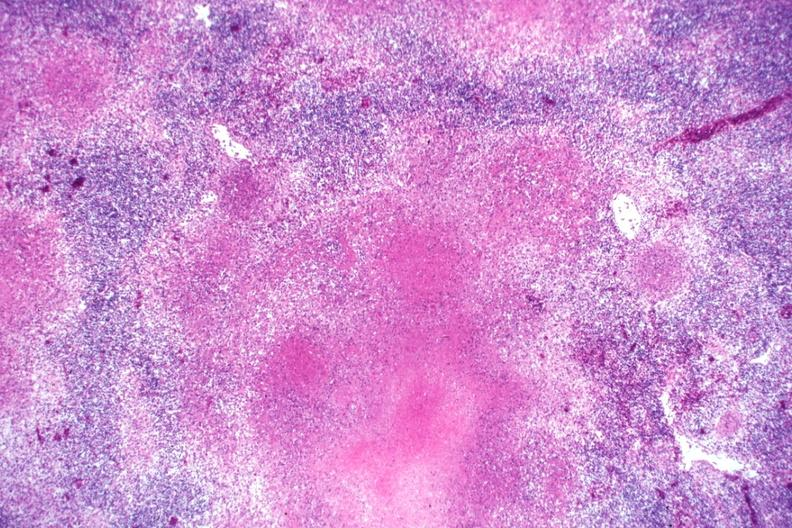what is present?
Answer the question using a single word or phrase. Lymph node 